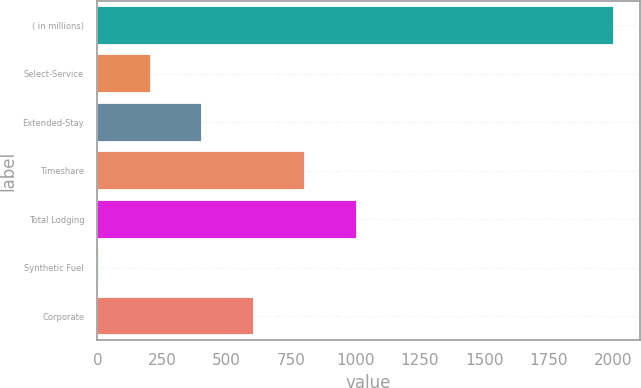<chart> <loc_0><loc_0><loc_500><loc_500><bar_chart><fcel>( in millions)<fcel>Select-Service<fcel>Extended-Stay<fcel>Timeshare<fcel>Total Lodging<fcel>Synthetic Fuel<fcel>Corporate<nl><fcel>2003<fcel>207.5<fcel>407<fcel>806<fcel>1005.5<fcel>8<fcel>606.5<nl></chart> 